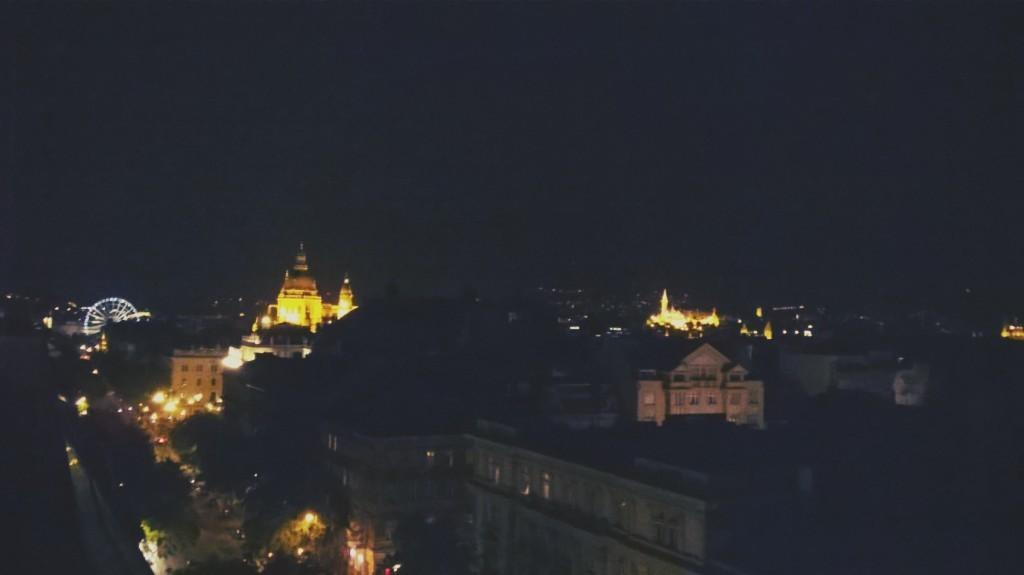What is the overall lighting condition in the image? The image is dark. What type of natural elements can be seen in the image? There are trees in the image. What type of man-made structures are present in the image? There are buildings in the image. What additional feature can be observed in the image? Lights are visible in the image. What type of vacation is being enjoyed by the people in the image? There are no people visible in the image, so it is impossible to determine if they are on vacation or not. What is the angle of the slope in the image? There is no slope present in the image; it features trees, buildings, and lights. 